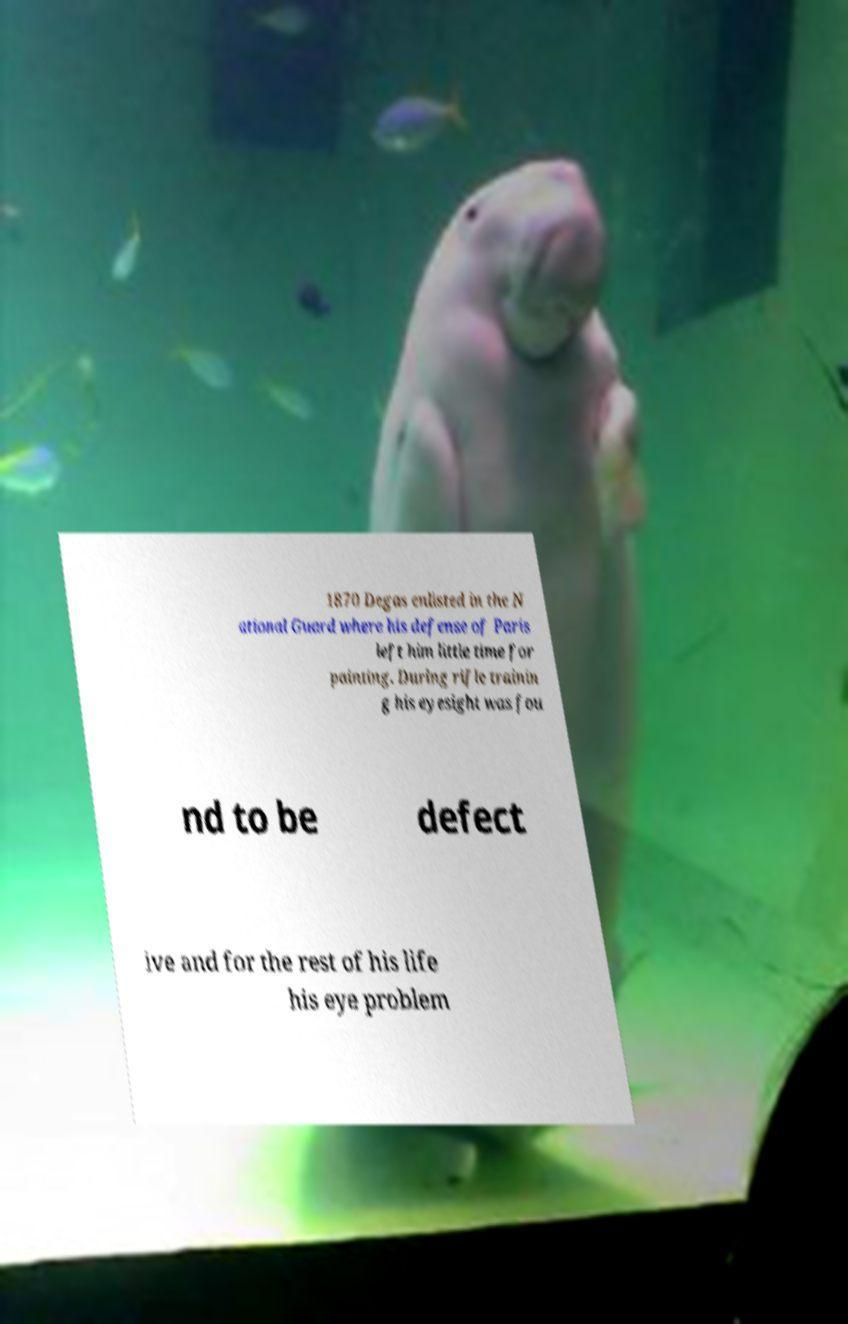I need the written content from this picture converted into text. Can you do that? 1870 Degas enlisted in the N ational Guard where his defense of Paris left him little time for painting. During rifle trainin g his eyesight was fou nd to be defect ive and for the rest of his life his eye problem 